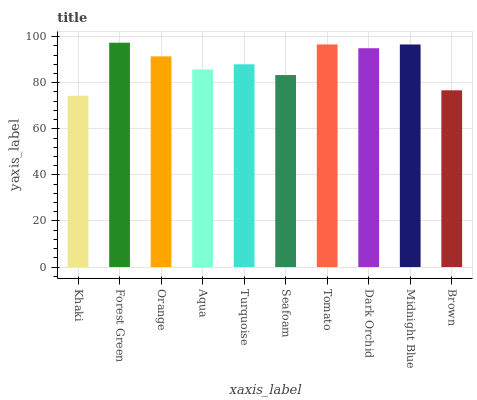Is Orange the minimum?
Answer yes or no. No. Is Orange the maximum?
Answer yes or no. No. Is Forest Green greater than Orange?
Answer yes or no. Yes. Is Orange less than Forest Green?
Answer yes or no. Yes. Is Orange greater than Forest Green?
Answer yes or no. No. Is Forest Green less than Orange?
Answer yes or no. No. Is Orange the high median?
Answer yes or no. Yes. Is Turquoise the low median?
Answer yes or no. Yes. Is Turquoise the high median?
Answer yes or no. No. Is Brown the low median?
Answer yes or no. No. 